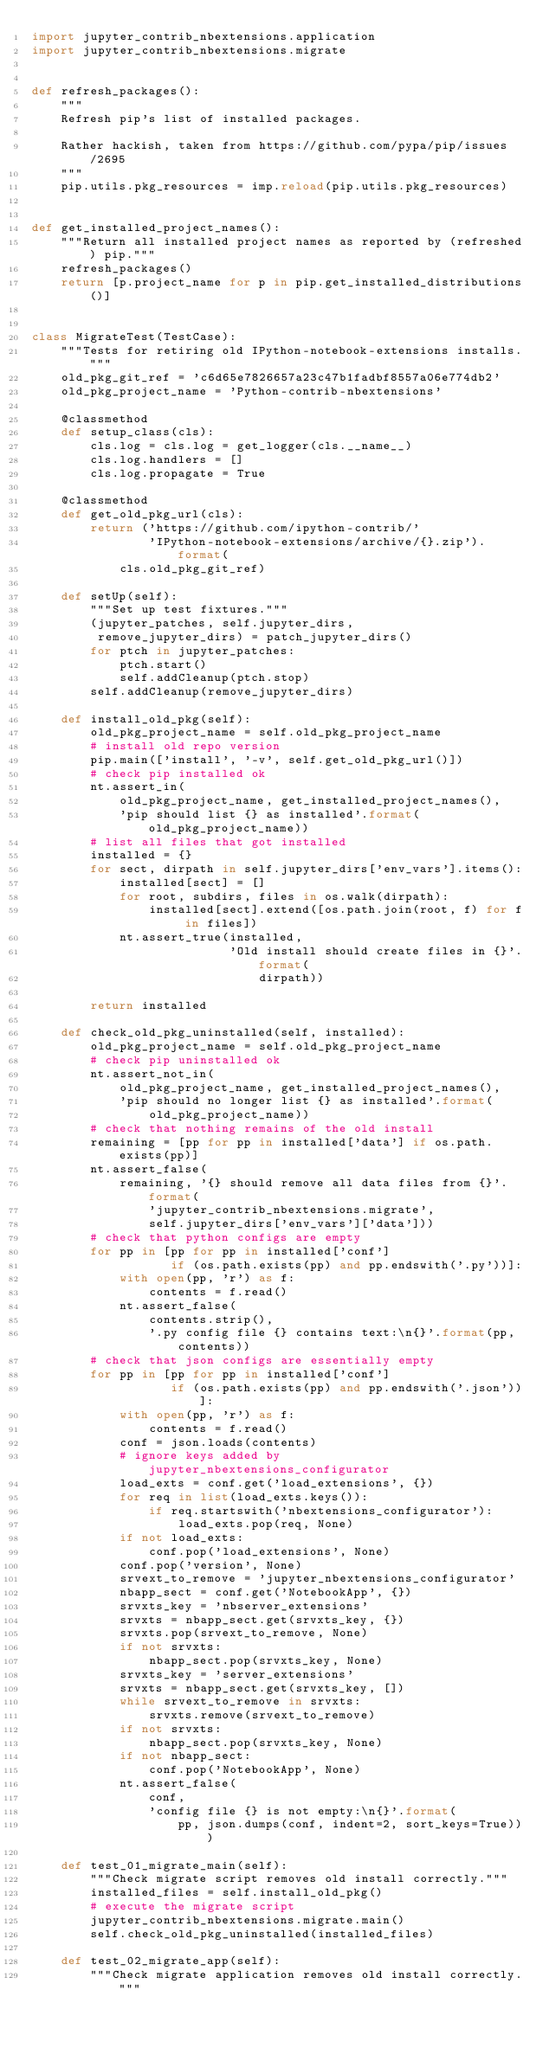<code> <loc_0><loc_0><loc_500><loc_500><_Python_>import jupyter_contrib_nbextensions.application
import jupyter_contrib_nbextensions.migrate


def refresh_packages():
    """
    Refresh pip's list of installed packages.

    Rather hackish, taken from https://github.com/pypa/pip/issues/2695
    """
    pip.utils.pkg_resources = imp.reload(pip.utils.pkg_resources)


def get_installed_project_names():
    """Return all installed project names as reported by (refreshed) pip."""
    refresh_packages()
    return [p.project_name for p in pip.get_installed_distributions()]


class MigrateTest(TestCase):
    """Tests for retiring old IPython-notebook-extensions installs."""
    old_pkg_git_ref = 'c6d65e7826657a23c47b1fadbf8557a06e774db2'
    old_pkg_project_name = 'Python-contrib-nbextensions'

    @classmethod
    def setup_class(cls):
        cls.log = cls.log = get_logger(cls.__name__)
        cls.log.handlers = []
        cls.log.propagate = True

    @classmethod
    def get_old_pkg_url(cls):
        return ('https://github.com/ipython-contrib/'
                'IPython-notebook-extensions/archive/{}.zip').format(
            cls.old_pkg_git_ref)

    def setUp(self):
        """Set up test fixtures."""
        (jupyter_patches, self.jupyter_dirs,
         remove_jupyter_dirs) = patch_jupyter_dirs()
        for ptch in jupyter_patches:
            ptch.start()
            self.addCleanup(ptch.stop)
        self.addCleanup(remove_jupyter_dirs)

    def install_old_pkg(self):
        old_pkg_project_name = self.old_pkg_project_name
        # install old repo version
        pip.main(['install', '-v', self.get_old_pkg_url()])
        # check pip installed ok
        nt.assert_in(
            old_pkg_project_name, get_installed_project_names(),
            'pip should list {} as installed'.format(old_pkg_project_name))
        # list all files that got installed
        installed = {}
        for sect, dirpath in self.jupyter_dirs['env_vars'].items():
            installed[sect] = []
            for root, subdirs, files in os.walk(dirpath):
                installed[sect].extend([os.path.join(root, f) for f in files])
            nt.assert_true(installed,
                           'Old install should create files in {}'.format(
                               dirpath))

        return installed

    def check_old_pkg_uninstalled(self, installed):
        old_pkg_project_name = self.old_pkg_project_name
        # check pip uninstalled ok
        nt.assert_not_in(
            old_pkg_project_name, get_installed_project_names(),
            'pip should no longer list {} as installed'.format(
                old_pkg_project_name))
        # check that nothing remains of the old install
        remaining = [pp for pp in installed['data'] if os.path.exists(pp)]
        nt.assert_false(
            remaining, '{} should remove all data files from {}'.format(
                'jupyter_contrib_nbextensions.migrate',
                self.jupyter_dirs['env_vars']['data']))
        # check that python configs are empty
        for pp in [pp for pp in installed['conf']
                   if (os.path.exists(pp) and pp.endswith('.py'))]:
            with open(pp, 'r') as f:
                contents = f.read()
            nt.assert_false(
                contents.strip(),
                '.py config file {} contains text:\n{}'.format(pp, contents))
        # check that json configs are essentially empty
        for pp in [pp for pp in installed['conf']
                   if (os.path.exists(pp) and pp.endswith('.json'))]:
            with open(pp, 'r') as f:
                contents = f.read()
            conf = json.loads(contents)
            # ignore keys added by jupyter_nbextensions_configurator
            load_exts = conf.get('load_extensions', {})
            for req in list(load_exts.keys()):
                if req.startswith('nbextensions_configurator'):
                    load_exts.pop(req, None)
            if not load_exts:
                conf.pop('load_extensions', None)
            conf.pop('version', None)
            srvext_to_remove = 'jupyter_nbextensions_configurator'
            nbapp_sect = conf.get('NotebookApp', {})
            srvxts_key = 'nbserver_extensions'
            srvxts = nbapp_sect.get(srvxts_key, {})
            srvxts.pop(srvext_to_remove, None)
            if not srvxts:
                nbapp_sect.pop(srvxts_key, None)
            srvxts_key = 'server_extensions'
            srvxts = nbapp_sect.get(srvxts_key, [])
            while srvext_to_remove in srvxts:
                srvxts.remove(srvext_to_remove)
            if not srvxts:
                nbapp_sect.pop(srvxts_key, None)
            if not nbapp_sect:
                conf.pop('NotebookApp', None)
            nt.assert_false(
                conf,
                'config file {} is not empty:\n{}'.format(
                    pp, json.dumps(conf, indent=2, sort_keys=True)))

    def test_01_migrate_main(self):
        """Check migrate script removes old install correctly."""
        installed_files = self.install_old_pkg()
        # execute the migrate script
        jupyter_contrib_nbextensions.migrate.main()
        self.check_old_pkg_uninstalled(installed_files)

    def test_02_migrate_app(self):
        """Check migrate application removes old install correctly."""</code> 